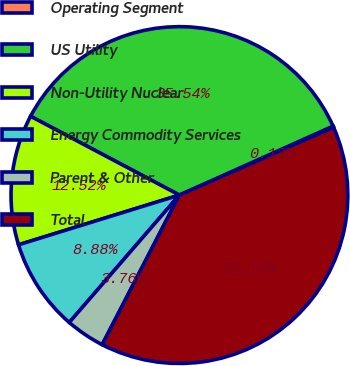Convert chart. <chart><loc_0><loc_0><loc_500><loc_500><pie_chart><fcel>Operating Segment<fcel>US Utility<fcel>Non-Utility Nuclear<fcel>Energy Commodity Services<fcel>Parent & Other<fcel>Total<nl><fcel>0.12%<fcel>35.53%<fcel>12.52%<fcel>8.88%<fcel>3.76%<fcel>39.17%<nl></chart> 